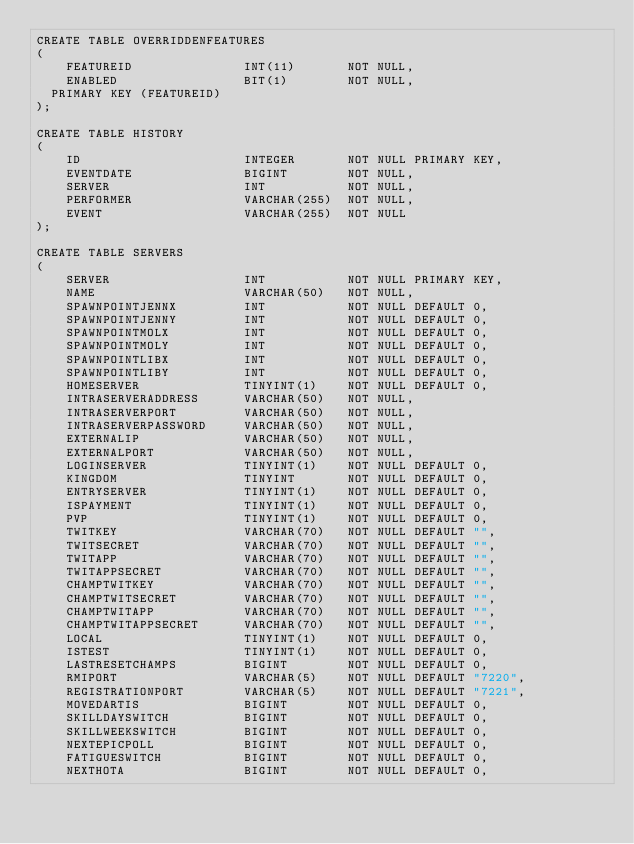Convert code to text. <code><loc_0><loc_0><loc_500><loc_500><_SQL_>CREATE TABLE OVERRIDDENFEATURES
(
    FEATUREID               INT(11)       NOT NULL,
    ENABLED                 BIT(1)        NOT NULL,
  PRIMARY KEY (FEATUREID)
);

CREATE TABLE HISTORY
(
    ID                      INTEGER       NOT NULL PRIMARY KEY,
    EVENTDATE               BIGINT        NOT NULL,
    SERVER                  INT           NOT NULL,
    PERFORMER               VARCHAR(255)  NOT NULL,
    EVENT                   VARCHAR(255)  NOT NULL
);

CREATE TABLE SERVERS 
( 
    SERVER                  INT           NOT NULL PRIMARY KEY,
    NAME                    VARCHAR(50)   NOT NULL,
    SPAWNPOINTJENNX         INT           NOT NULL DEFAULT 0,
    SPAWNPOINTJENNY         INT           NOT NULL DEFAULT 0,
    SPAWNPOINTMOLX          INT           NOT NULL DEFAULT 0,
    SPAWNPOINTMOLY          INT           NOT NULL DEFAULT 0,
    SPAWNPOINTLIBX          INT           NOT NULL DEFAULT 0,
    SPAWNPOINTLIBY          INT           NOT NULL DEFAULT 0,
    HOMESERVER              TINYINT(1)    NOT NULL DEFAULT 0,
    INTRASERVERADDRESS      VARCHAR(50)   NOT NULL,
    INTRASERVERPORT         VARCHAR(50)   NOT NULL,
    INTRASERVERPASSWORD     VARCHAR(50)   NOT NULL,
    EXTERNALIP              VARCHAR(50)   NOT NULL,
    EXTERNALPORT            VARCHAR(50)   NOT NULL,
    LOGINSERVER             TINYINT(1)    NOT NULL DEFAULT 0,
    KINGDOM                 TINYINT       NOT NULL DEFAULT 0,
    ENTRYSERVER             TINYINT(1)    NOT NULL DEFAULT 0,
    ISPAYMENT               TINYINT(1)    NOT NULL DEFAULT 0,
    PVP                     TINYINT(1)    NOT NULL DEFAULT 0,
    TWITKEY                 VARCHAR(70)   NOT NULL DEFAULT "",
    TWITSECRET              VARCHAR(70)   NOT NULL DEFAULT "",
    TWITAPP                 VARCHAR(70)   NOT NULL DEFAULT "",
    TWITAPPSECRET           VARCHAR(70)   NOT NULL DEFAULT "",
    CHAMPTWITKEY            VARCHAR(70)   NOT NULL DEFAULT "",
    CHAMPTWITSECRET         VARCHAR(70)   NOT NULL DEFAULT "",
    CHAMPTWITAPP            VARCHAR(70)   NOT NULL DEFAULT "",
    CHAMPTWITAPPSECRET      VARCHAR(70)   NOT NULL DEFAULT "",
    LOCAL                   TINYINT(1)    NOT NULL DEFAULT 0,
    ISTEST                  TINYINT(1)    NOT NULL DEFAULT 0,
    LASTRESETCHAMPS         BIGINT        NOT NULL DEFAULT 0,
    RMIPORT                 VARCHAR(5)    NOT NULL DEFAULT "7220",
    REGISTRATIONPORT        VARCHAR(5)    NOT NULL DEFAULT "7221",
    MOVEDARTIS              BIGINT        NOT NULL DEFAULT 0,
    SKILLDAYSWITCH          BIGINT        NOT NULL DEFAULT 0,
    SKILLWEEKSWITCH         BIGINT        NOT NULL DEFAULT 0,
    NEXTEPICPOLL            BIGINT        NOT NULL DEFAULT 0,
    FATIGUESWITCH           BIGINT        NOT NULL DEFAULT 0,
    NEXTHOTA                BIGINT        NOT NULL DEFAULT 0,</code> 